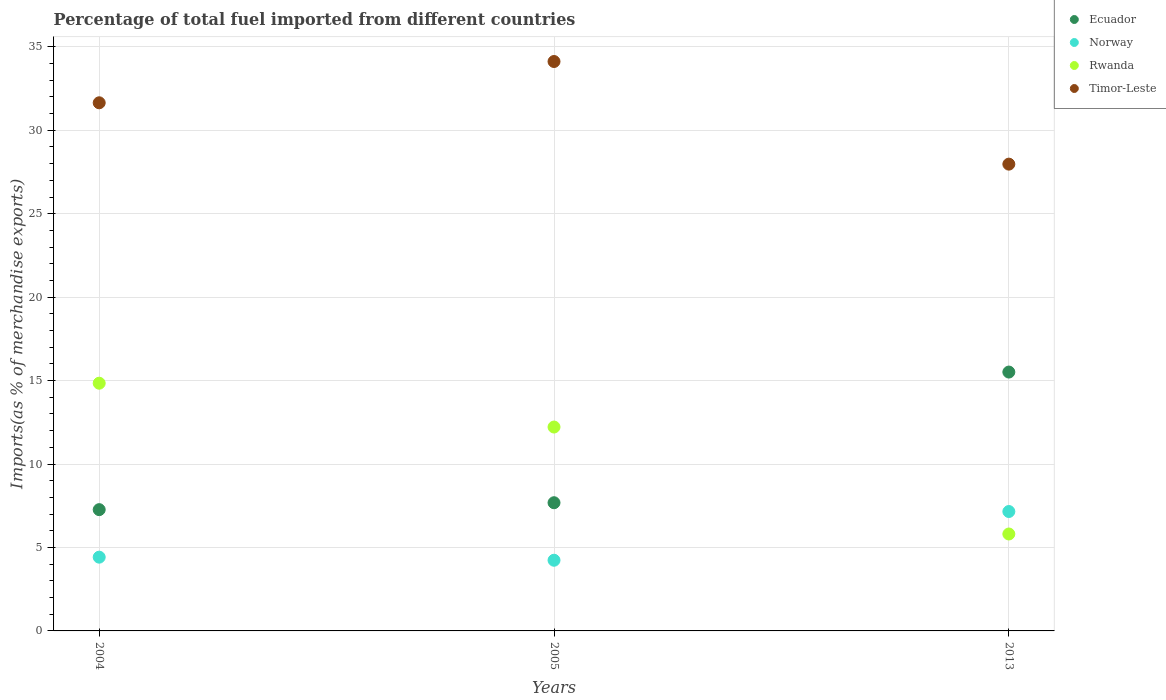What is the percentage of imports to different countries in Ecuador in 2013?
Your answer should be compact. 15.51. Across all years, what is the maximum percentage of imports to different countries in Norway?
Offer a very short reply. 7.16. Across all years, what is the minimum percentage of imports to different countries in Timor-Leste?
Your answer should be very brief. 27.97. In which year was the percentage of imports to different countries in Rwanda minimum?
Offer a very short reply. 2013. What is the total percentage of imports to different countries in Norway in the graph?
Offer a terse response. 15.81. What is the difference between the percentage of imports to different countries in Rwanda in 2004 and that in 2005?
Your answer should be compact. 2.63. What is the difference between the percentage of imports to different countries in Norway in 2004 and the percentage of imports to different countries in Timor-Leste in 2013?
Provide a short and direct response. -23.55. What is the average percentage of imports to different countries in Timor-Leste per year?
Ensure brevity in your answer.  31.25. In the year 2004, what is the difference between the percentage of imports to different countries in Timor-Leste and percentage of imports to different countries in Norway?
Make the answer very short. 27.23. What is the ratio of the percentage of imports to different countries in Ecuador in 2004 to that in 2013?
Offer a very short reply. 0.47. Is the percentage of imports to different countries in Rwanda in 2005 less than that in 2013?
Offer a very short reply. No. What is the difference between the highest and the second highest percentage of imports to different countries in Norway?
Make the answer very short. 2.74. What is the difference between the highest and the lowest percentage of imports to different countries in Timor-Leste?
Your response must be concise. 6.15. Is it the case that in every year, the sum of the percentage of imports to different countries in Rwanda and percentage of imports to different countries in Norway  is greater than the sum of percentage of imports to different countries in Timor-Leste and percentage of imports to different countries in Ecuador?
Your answer should be compact. Yes. Is it the case that in every year, the sum of the percentage of imports to different countries in Ecuador and percentage of imports to different countries in Timor-Leste  is greater than the percentage of imports to different countries in Norway?
Provide a succinct answer. Yes. Does the percentage of imports to different countries in Timor-Leste monotonically increase over the years?
Provide a succinct answer. No. Is the percentage of imports to different countries in Timor-Leste strictly greater than the percentage of imports to different countries in Ecuador over the years?
Make the answer very short. Yes. How many years are there in the graph?
Provide a succinct answer. 3. Are the values on the major ticks of Y-axis written in scientific E-notation?
Provide a short and direct response. No. Does the graph contain any zero values?
Ensure brevity in your answer.  No. Does the graph contain grids?
Provide a short and direct response. Yes. What is the title of the graph?
Ensure brevity in your answer.  Percentage of total fuel imported from different countries. Does "Cuba" appear as one of the legend labels in the graph?
Your answer should be very brief. No. What is the label or title of the Y-axis?
Keep it short and to the point. Imports(as % of merchandise exports). What is the Imports(as % of merchandise exports) of Ecuador in 2004?
Make the answer very short. 7.27. What is the Imports(as % of merchandise exports) of Norway in 2004?
Keep it short and to the point. 4.42. What is the Imports(as % of merchandise exports) in Rwanda in 2004?
Make the answer very short. 14.84. What is the Imports(as % of merchandise exports) of Timor-Leste in 2004?
Provide a succinct answer. 31.65. What is the Imports(as % of merchandise exports) in Ecuador in 2005?
Ensure brevity in your answer.  7.68. What is the Imports(as % of merchandise exports) in Norway in 2005?
Keep it short and to the point. 4.24. What is the Imports(as % of merchandise exports) in Rwanda in 2005?
Provide a succinct answer. 12.22. What is the Imports(as % of merchandise exports) of Timor-Leste in 2005?
Your answer should be compact. 34.12. What is the Imports(as % of merchandise exports) of Ecuador in 2013?
Provide a succinct answer. 15.51. What is the Imports(as % of merchandise exports) of Norway in 2013?
Make the answer very short. 7.16. What is the Imports(as % of merchandise exports) in Rwanda in 2013?
Offer a very short reply. 5.81. What is the Imports(as % of merchandise exports) of Timor-Leste in 2013?
Your answer should be compact. 27.97. Across all years, what is the maximum Imports(as % of merchandise exports) of Ecuador?
Keep it short and to the point. 15.51. Across all years, what is the maximum Imports(as % of merchandise exports) of Norway?
Ensure brevity in your answer.  7.16. Across all years, what is the maximum Imports(as % of merchandise exports) of Rwanda?
Your answer should be very brief. 14.84. Across all years, what is the maximum Imports(as % of merchandise exports) of Timor-Leste?
Keep it short and to the point. 34.12. Across all years, what is the minimum Imports(as % of merchandise exports) of Ecuador?
Make the answer very short. 7.27. Across all years, what is the minimum Imports(as % of merchandise exports) in Norway?
Your answer should be very brief. 4.24. Across all years, what is the minimum Imports(as % of merchandise exports) of Rwanda?
Offer a terse response. 5.81. Across all years, what is the minimum Imports(as % of merchandise exports) of Timor-Leste?
Provide a succinct answer. 27.97. What is the total Imports(as % of merchandise exports) of Ecuador in the graph?
Offer a very short reply. 30.46. What is the total Imports(as % of merchandise exports) in Norway in the graph?
Your response must be concise. 15.81. What is the total Imports(as % of merchandise exports) in Rwanda in the graph?
Your answer should be very brief. 32.87. What is the total Imports(as % of merchandise exports) of Timor-Leste in the graph?
Your answer should be compact. 93.74. What is the difference between the Imports(as % of merchandise exports) of Ecuador in 2004 and that in 2005?
Offer a terse response. -0.41. What is the difference between the Imports(as % of merchandise exports) in Norway in 2004 and that in 2005?
Your answer should be very brief. 0.18. What is the difference between the Imports(as % of merchandise exports) of Rwanda in 2004 and that in 2005?
Give a very brief answer. 2.63. What is the difference between the Imports(as % of merchandise exports) of Timor-Leste in 2004 and that in 2005?
Ensure brevity in your answer.  -2.47. What is the difference between the Imports(as % of merchandise exports) in Ecuador in 2004 and that in 2013?
Offer a very short reply. -8.24. What is the difference between the Imports(as % of merchandise exports) of Norway in 2004 and that in 2013?
Your answer should be very brief. -2.74. What is the difference between the Imports(as % of merchandise exports) in Rwanda in 2004 and that in 2013?
Provide a succinct answer. 9.04. What is the difference between the Imports(as % of merchandise exports) in Timor-Leste in 2004 and that in 2013?
Provide a short and direct response. 3.68. What is the difference between the Imports(as % of merchandise exports) in Ecuador in 2005 and that in 2013?
Your answer should be very brief. -7.83. What is the difference between the Imports(as % of merchandise exports) of Norway in 2005 and that in 2013?
Give a very brief answer. -2.92. What is the difference between the Imports(as % of merchandise exports) of Rwanda in 2005 and that in 2013?
Make the answer very short. 6.41. What is the difference between the Imports(as % of merchandise exports) of Timor-Leste in 2005 and that in 2013?
Your answer should be very brief. 6.15. What is the difference between the Imports(as % of merchandise exports) in Ecuador in 2004 and the Imports(as % of merchandise exports) in Norway in 2005?
Provide a short and direct response. 3.03. What is the difference between the Imports(as % of merchandise exports) in Ecuador in 2004 and the Imports(as % of merchandise exports) in Rwanda in 2005?
Your answer should be very brief. -4.95. What is the difference between the Imports(as % of merchandise exports) of Ecuador in 2004 and the Imports(as % of merchandise exports) of Timor-Leste in 2005?
Your answer should be compact. -26.85. What is the difference between the Imports(as % of merchandise exports) of Norway in 2004 and the Imports(as % of merchandise exports) of Rwanda in 2005?
Your answer should be very brief. -7.8. What is the difference between the Imports(as % of merchandise exports) in Norway in 2004 and the Imports(as % of merchandise exports) in Timor-Leste in 2005?
Provide a succinct answer. -29.7. What is the difference between the Imports(as % of merchandise exports) in Rwanda in 2004 and the Imports(as % of merchandise exports) in Timor-Leste in 2005?
Offer a very short reply. -19.28. What is the difference between the Imports(as % of merchandise exports) of Ecuador in 2004 and the Imports(as % of merchandise exports) of Norway in 2013?
Provide a short and direct response. 0.11. What is the difference between the Imports(as % of merchandise exports) of Ecuador in 2004 and the Imports(as % of merchandise exports) of Rwanda in 2013?
Your answer should be compact. 1.46. What is the difference between the Imports(as % of merchandise exports) in Ecuador in 2004 and the Imports(as % of merchandise exports) in Timor-Leste in 2013?
Offer a very short reply. -20.7. What is the difference between the Imports(as % of merchandise exports) in Norway in 2004 and the Imports(as % of merchandise exports) in Rwanda in 2013?
Your answer should be very brief. -1.39. What is the difference between the Imports(as % of merchandise exports) of Norway in 2004 and the Imports(as % of merchandise exports) of Timor-Leste in 2013?
Offer a terse response. -23.55. What is the difference between the Imports(as % of merchandise exports) in Rwanda in 2004 and the Imports(as % of merchandise exports) in Timor-Leste in 2013?
Provide a succinct answer. -13.13. What is the difference between the Imports(as % of merchandise exports) in Ecuador in 2005 and the Imports(as % of merchandise exports) in Norway in 2013?
Make the answer very short. 0.53. What is the difference between the Imports(as % of merchandise exports) of Ecuador in 2005 and the Imports(as % of merchandise exports) of Rwanda in 2013?
Your answer should be very brief. 1.87. What is the difference between the Imports(as % of merchandise exports) in Ecuador in 2005 and the Imports(as % of merchandise exports) in Timor-Leste in 2013?
Make the answer very short. -20.29. What is the difference between the Imports(as % of merchandise exports) of Norway in 2005 and the Imports(as % of merchandise exports) of Rwanda in 2013?
Give a very brief answer. -1.57. What is the difference between the Imports(as % of merchandise exports) in Norway in 2005 and the Imports(as % of merchandise exports) in Timor-Leste in 2013?
Keep it short and to the point. -23.73. What is the difference between the Imports(as % of merchandise exports) of Rwanda in 2005 and the Imports(as % of merchandise exports) of Timor-Leste in 2013?
Your response must be concise. -15.75. What is the average Imports(as % of merchandise exports) in Ecuador per year?
Make the answer very short. 10.15. What is the average Imports(as % of merchandise exports) of Norway per year?
Keep it short and to the point. 5.27. What is the average Imports(as % of merchandise exports) in Rwanda per year?
Provide a short and direct response. 10.96. What is the average Imports(as % of merchandise exports) of Timor-Leste per year?
Keep it short and to the point. 31.25. In the year 2004, what is the difference between the Imports(as % of merchandise exports) of Ecuador and Imports(as % of merchandise exports) of Norway?
Provide a short and direct response. 2.85. In the year 2004, what is the difference between the Imports(as % of merchandise exports) of Ecuador and Imports(as % of merchandise exports) of Rwanda?
Your answer should be very brief. -7.58. In the year 2004, what is the difference between the Imports(as % of merchandise exports) of Ecuador and Imports(as % of merchandise exports) of Timor-Leste?
Ensure brevity in your answer.  -24.38. In the year 2004, what is the difference between the Imports(as % of merchandise exports) of Norway and Imports(as % of merchandise exports) of Rwanda?
Ensure brevity in your answer.  -10.42. In the year 2004, what is the difference between the Imports(as % of merchandise exports) of Norway and Imports(as % of merchandise exports) of Timor-Leste?
Offer a terse response. -27.23. In the year 2004, what is the difference between the Imports(as % of merchandise exports) in Rwanda and Imports(as % of merchandise exports) in Timor-Leste?
Provide a short and direct response. -16.8. In the year 2005, what is the difference between the Imports(as % of merchandise exports) of Ecuador and Imports(as % of merchandise exports) of Norway?
Offer a very short reply. 3.45. In the year 2005, what is the difference between the Imports(as % of merchandise exports) in Ecuador and Imports(as % of merchandise exports) in Rwanda?
Keep it short and to the point. -4.54. In the year 2005, what is the difference between the Imports(as % of merchandise exports) in Ecuador and Imports(as % of merchandise exports) in Timor-Leste?
Make the answer very short. -26.44. In the year 2005, what is the difference between the Imports(as % of merchandise exports) of Norway and Imports(as % of merchandise exports) of Rwanda?
Your response must be concise. -7.98. In the year 2005, what is the difference between the Imports(as % of merchandise exports) of Norway and Imports(as % of merchandise exports) of Timor-Leste?
Your response must be concise. -29.88. In the year 2005, what is the difference between the Imports(as % of merchandise exports) of Rwanda and Imports(as % of merchandise exports) of Timor-Leste?
Your answer should be compact. -21.9. In the year 2013, what is the difference between the Imports(as % of merchandise exports) of Ecuador and Imports(as % of merchandise exports) of Norway?
Offer a terse response. 8.36. In the year 2013, what is the difference between the Imports(as % of merchandise exports) in Ecuador and Imports(as % of merchandise exports) in Rwanda?
Offer a terse response. 9.7. In the year 2013, what is the difference between the Imports(as % of merchandise exports) in Ecuador and Imports(as % of merchandise exports) in Timor-Leste?
Ensure brevity in your answer.  -12.46. In the year 2013, what is the difference between the Imports(as % of merchandise exports) in Norway and Imports(as % of merchandise exports) in Rwanda?
Make the answer very short. 1.35. In the year 2013, what is the difference between the Imports(as % of merchandise exports) in Norway and Imports(as % of merchandise exports) in Timor-Leste?
Your answer should be compact. -20.82. In the year 2013, what is the difference between the Imports(as % of merchandise exports) of Rwanda and Imports(as % of merchandise exports) of Timor-Leste?
Keep it short and to the point. -22.16. What is the ratio of the Imports(as % of merchandise exports) of Ecuador in 2004 to that in 2005?
Your answer should be compact. 0.95. What is the ratio of the Imports(as % of merchandise exports) of Norway in 2004 to that in 2005?
Make the answer very short. 1.04. What is the ratio of the Imports(as % of merchandise exports) of Rwanda in 2004 to that in 2005?
Your answer should be very brief. 1.21. What is the ratio of the Imports(as % of merchandise exports) in Timor-Leste in 2004 to that in 2005?
Provide a succinct answer. 0.93. What is the ratio of the Imports(as % of merchandise exports) of Ecuador in 2004 to that in 2013?
Offer a terse response. 0.47. What is the ratio of the Imports(as % of merchandise exports) of Norway in 2004 to that in 2013?
Make the answer very short. 0.62. What is the ratio of the Imports(as % of merchandise exports) in Rwanda in 2004 to that in 2013?
Your answer should be very brief. 2.56. What is the ratio of the Imports(as % of merchandise exports) of Timor-Leste in 2004 to that in 2013?
Offer a terse response. 1.13. What is the ratio of the Imports(as % of merchandise exports) in Ecuador in 2005 to that in 2013?
Your answer should be compact. 0.5. What is the ratio of the Imports(as % of merchandise exports) of Norway in 2005 to that in 2013?
Your answer should be very brief. 0.59. What is the ratio of the Imports(as % of merchandise exports) in Rwanda in 2005 to that in 2013?
Your answer should be very brief. 2.1. What is the ratio of the Imports(as % of merchandise exports) of Timor-Leste in 2005 to that in 2013?
Ensure brevity in your answer.  1.22. What is the difference between the highest and the second highest Imports(as % of merchandise exports) of Ecuador?
Make the answer very short. 7.83. What is the difference between the highest and the second highest Imports(as % of merchandise exports) of Norway?
Keep it short and to the point. 2.74. What is the difference between the highest and the second highest Imports(as % of merchandise exports) in Rwanda?
Your answer should be very brief. 2.63. What is the difference between the highest and the second highest Imports(as % of merchandise exports) in Timor-Leste?
Provide a short and direct response. 2.47. What is the difference between the highest and the lowest Imports(as % of merchandise exports) in Ecuador?
Your answer should be compact. 8.24. What is the difference between the highest and the lowest Imports(as % of merchandise exports) of Norway?
Provide a succinct answer. 2.92. What is the difference between the highest and the lowest Imports(as % of merchandise exports) of Rwanda?
Your response must be concise. 9.04. What is the difference between the highest and the lowest Imports(as % of merchandise exports) in Timor-Leste?
Keep it short and to the point. 6.15. 